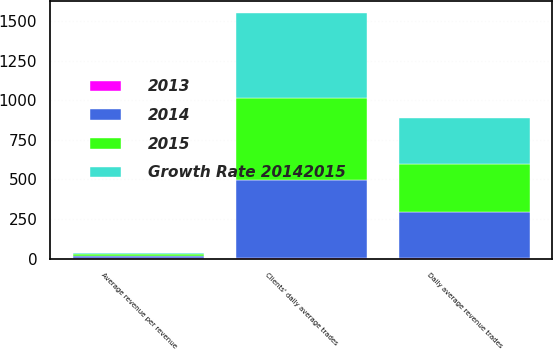Convert chart. <chart><loc_0><loc_0><loc_500><loc_500><stacked_bar_chart><ecel><fcel>Daily average revenue trades<fcel>Clients' daily average trades<fcel>Average revenue per revenue<nl><fcel>2013<fcel>2<fcel>4<fcel>2<nl><fcel>Growth Rate 20142015<fcel>292<fcel>536.9<fcel>11.83<nl><fcel>2015<fcel>298.2<fcel>516.8<fcel>12.13<nl><fcel>2014<fcel>295<fcel>490.5<fcel>12.31<nl></chart> 